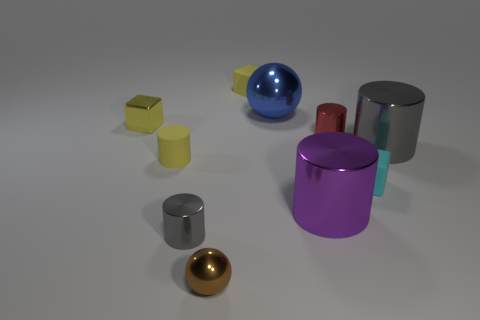There is a tiny yellow object that is both to the right of the metal cube and behind the small rubber cylinder; what is its material?
Keep it short and to the point. Rubber. There is a blue shiny thing; does it have the same size as the gray metallic object that is right of the small red shiny object?
Make the answer very short. Yes. Are there any green objects?
Your response must be concise. No. There is a large purple thing that is the same shape as the red metallic thing; what is its material?
Offer a terse response. Metal. There is a ball that is in front of the big metallic sphere that is behind the gray metallic cylinder behind the small gray cylinder; how big is it?
Keep it short and to the point. Small. There is a tiny brown metal sphere; are there any small objects behind it?
Your response must be concise. Yes. What size is the yellow thing that is the same material as the large purple cylinder?
Ensure brevity in your answer.  Small. How many big blue objects have the same shape as the red object?
Your response must be concise. 0. Does the yellow cylinder have the same material as the small cylinder that is on the right side of the tiny metallic sphere?
Keep it short and to the point. No. Are there more tiny yellow rubber cylinders on the left side of the rubber cylinder than purple cylinders?
Make the answer very short. No. 